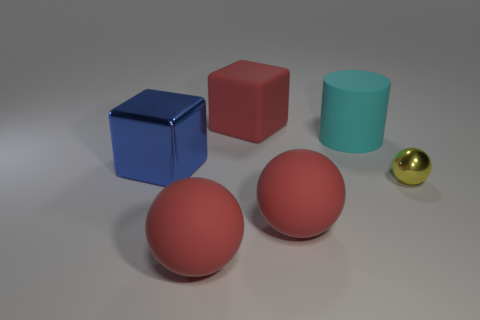Subtract all red spheres. How many were subtracted if there are1red spheres left? 1 Subtract all small metallic balls. How many balls are left? 2 Add 1 big cyan matte things. How many objects exist? 7 Subtract all cylinders. How many objects are left? 5 Add 3 large cyan metallic objects. How many large cyan metallic objects exist? 3 Subtract 0 red cylinders. How many objects are left? 6 Subtract all red shiny cylinders. Subtract all large red blocks. How many objects are left? 5 Add 1 large cyan matte objects. How many large cyan matte objects are left? 2 